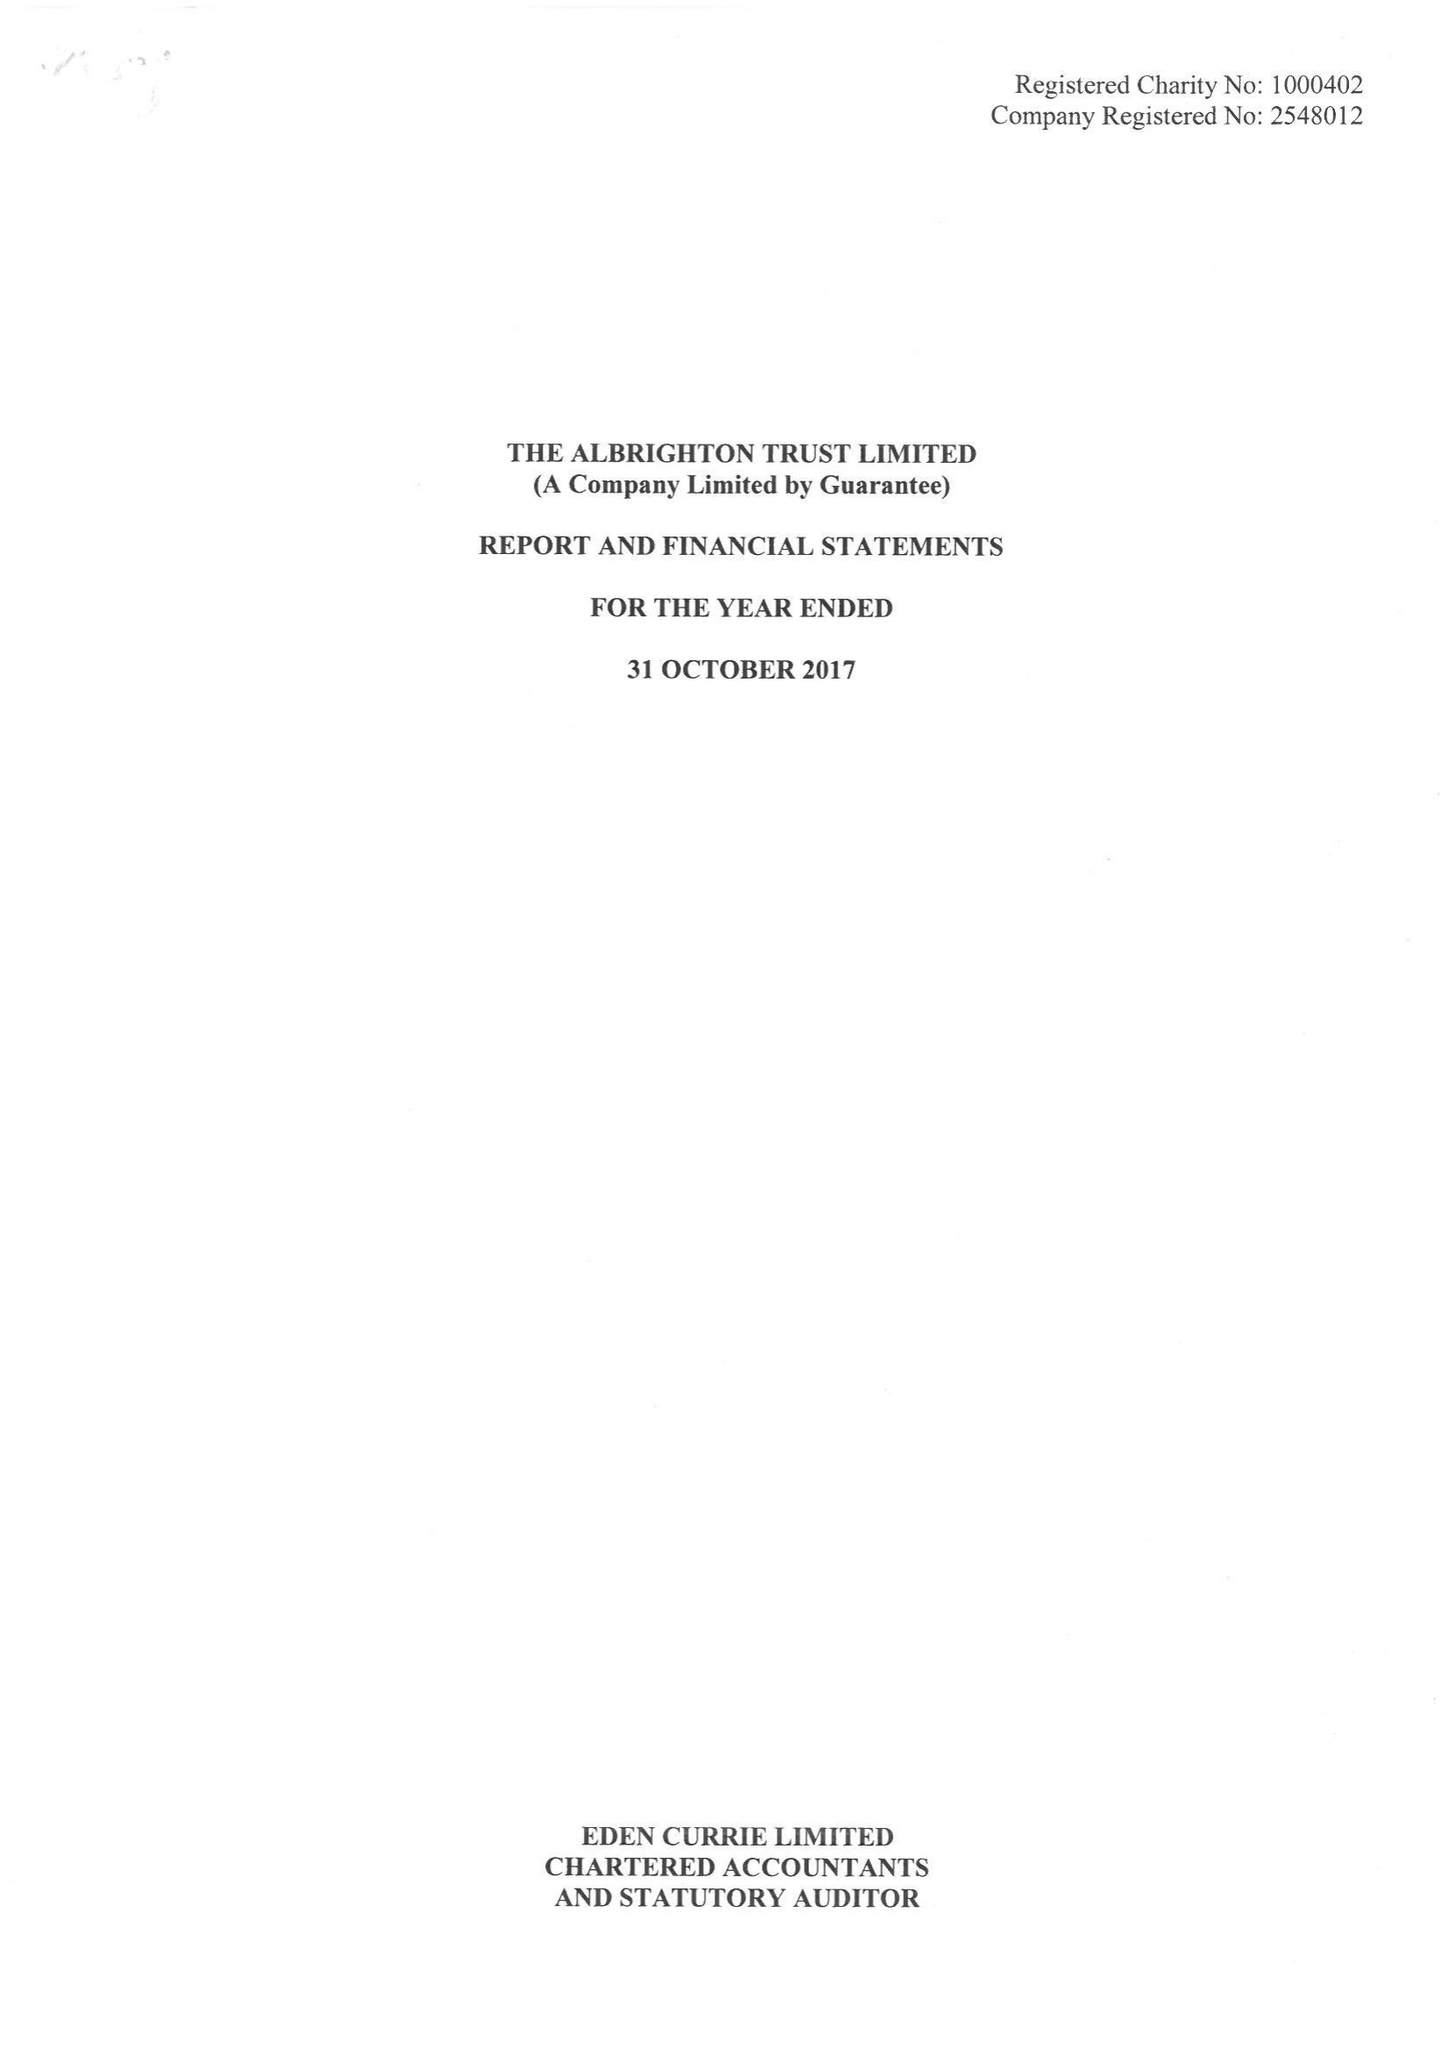What is the value for the address__postcode?
Answer the question using a single word or phrase. WV7 3FL 